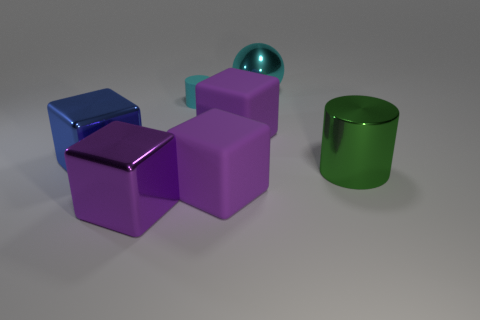Subtract all purple cubes. How many were subtracted if there are1purple cubes left? 2 Subtract all purple cylinders. How many purple cubes are left? 3 Add 2 large metallic blocks. How many objects exist? 9 Subtract all spheres. How many objects are left? 6 Subtract 0 gray cubes. How many objects are left? 7 Subtract all green metal objects. Subtract all shiny cubes. How many objects are left? 4 Add 4 big purple shiny cubes. How many big purple shiny cubes are left? 5 Add 7 green cylinders. How many green cylinders exist? 8 